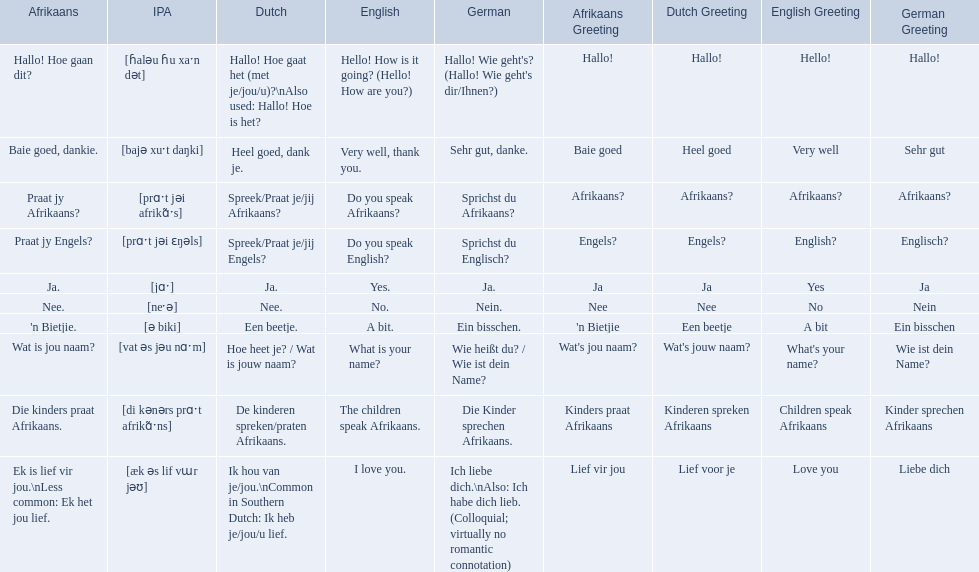How would you say the phrase the children speak afrikaans in afrikaans? Die kinders praat Afrikaans. How would you say the previous phrase in german? Die Kinder sprechen Afrikaans. What are all of the afrikaans phrases shown in the table? Hallo! Hoe gaan dit?, Baie goed, dankie., Praat jy Afrikaans?, Praat jy Engels?, Ja., Nee., 'n Bietjie., Wat is jou naam?, Die kinders praat Afrikaans., Ek is lief vir jou.\nLess common: Ek het jou lief. Of those, which translates into english as do you speak afrikaans?? Praat jy Afrikaans?. 